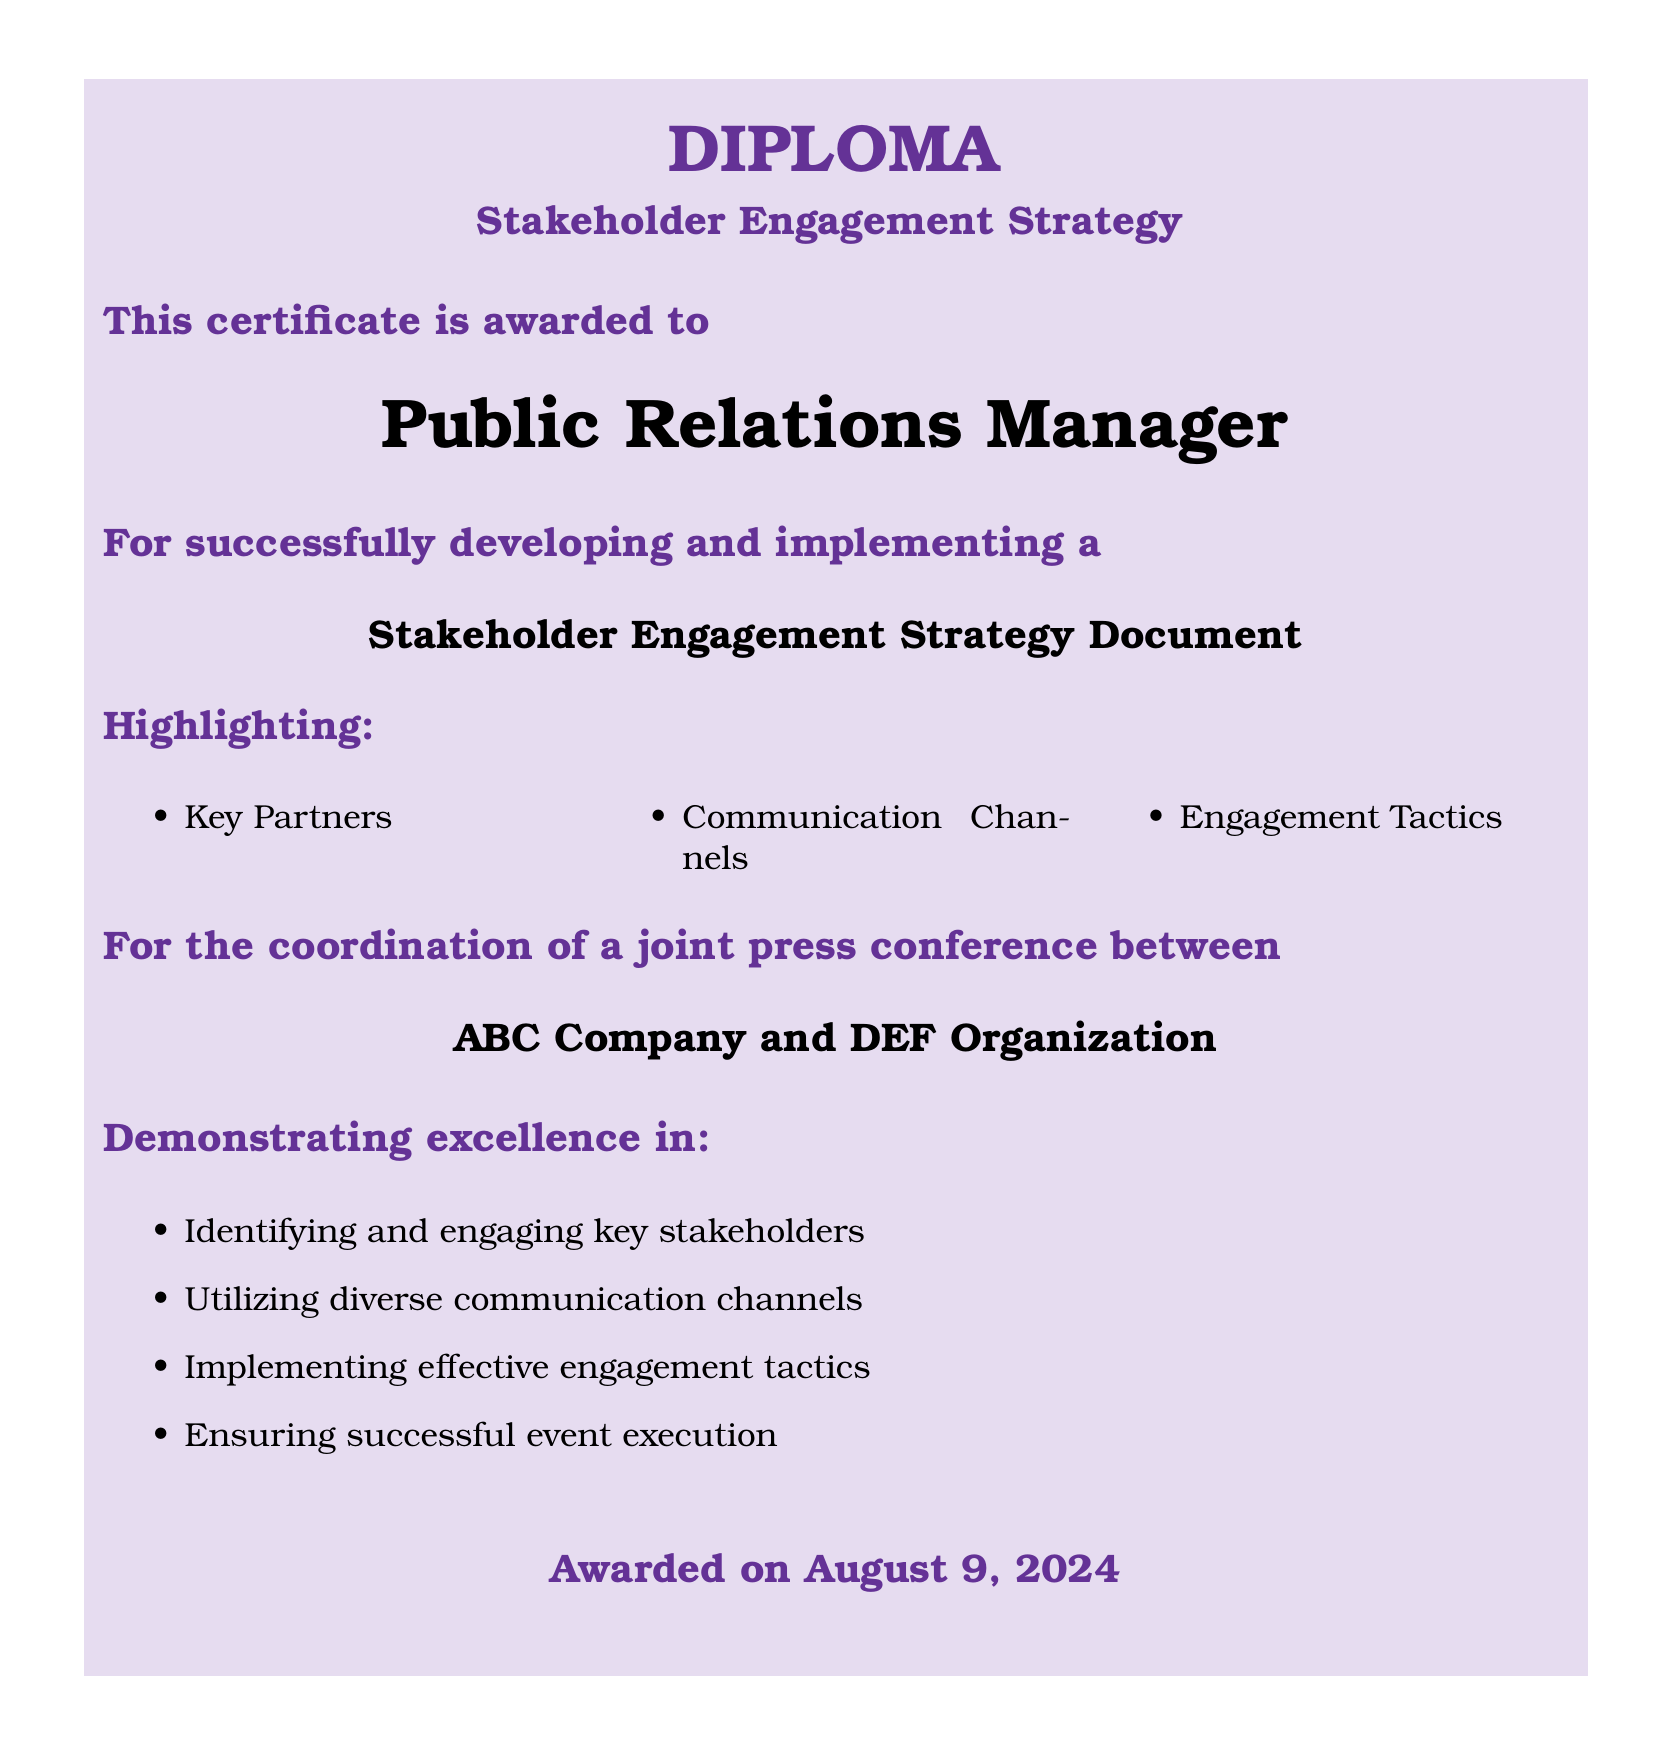What is the title of the document? The title of the document is stated prominently at the top, indicating its focus on a specific strategy.
Answer: Stakeholder Engagement Strategy Who is awarded the diploma? The diploma specifies the recipient of the award clearly in the highlighted section.
Answer: Public Relations Manager Which two organizations are mentioned in the document? The document lists the organizations involved in the joint press conference in a dedicated section.
Answer: ABC Company and DEF Organization What are the three key components highlighted in the document? The document outlines three main areas of focus related to the strategy, which are listed in a bullet format.
Answer: Key Partners, Communication Channels, Engagement Tactics What date is the award given? The date is indicated at the bottom of the document, represented as the current date at the time of the award.
Answer: Today What is demonstrated excellence in according to the document? The document lists specific areas of excellence in stakeholder engagement strategy that the recipient has demonstrated.
Answer: Identifying and engaging key stakeholders What is the color of the light purple section in the document? The document uses a specific light purple shade for the color box surrounding the main text.
Answer: Light purple In how many columns are the highlighted components presented? The layout of the highlighted components is structured into a specific number of columns as indicated in the document.
Answer: Three columns 